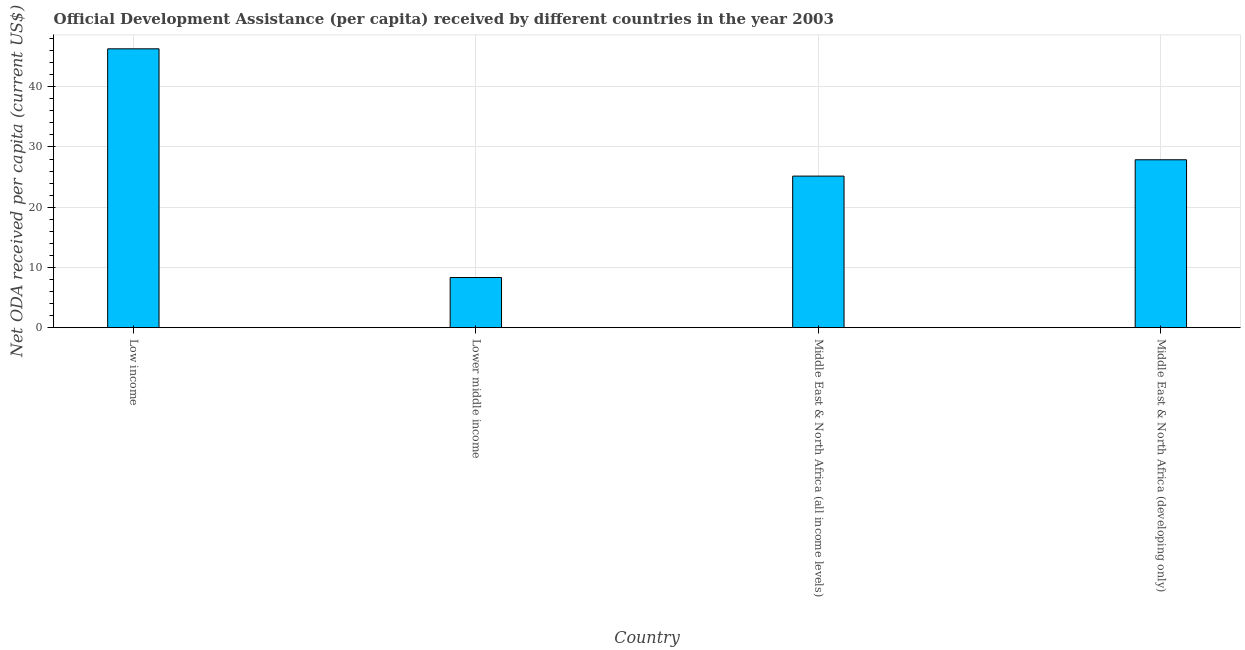Does the graph contain grids?
Make the answer very short. Yes. What is the title of the graph?
Offer a very short reply. Official Development Assistance (per capita) received by different countries in the year 2003. What is the label or title of the Y-axis?
Ensure brevity in your answer.  Net ODA received per capita (current US$). What is the net oda received per capita in Middle East & North Africa (developing only)?
Give a very brief answer. 27.88. Across all countries, what is the maximum net oda received per capita?
Provide a succinct answer. 46.3. Across all countries, what is the minimum net oda received per capita?
Offer a very short reply. 8.33. In which country was the net oda received per capita minimum?
Give a very brief answer. Lower middle income. What is the sum of the net oda received per capita?
Your answer should be compact. 107.67. What is the difference between the net oda received per capita in Low income and Lower middle income?
Offer a terse response. 37.98. What is the average net oda received per capita per country?
Your answer should be very brief. 26.92. What is the median net oda received per capita?
Provide a short and direct response. 26.52. In how many countries, is the net oda received per capita greater than 6 US$?
Keep it short and to the point. 4. What is the ratio of the net oda received per capita in Low income to that in Middle East & North Africa (all income levels)?
Provide a short and direct response. 1.84. Is the net oda received per capita in Low income less than that in Middle East & North Africa (all income levels)?
Keep it short and to the point. No. What is the difference between the highest and the second highest net oda received per capita?
Your answer should be very brief. 18.42. What is the difference between the highest and the lowest net oda received per capita?
Offer a very short reply. 37.98. In how many countries, is the net oda received per capita greater than the average net oda received per capita taken over all countries?
Your answer should be very brief. 2. Are all the bars in the graph horizontal?
Provide a short and direct response. No. How many countries are there in the graph?
Ensure brevity in your answer.  4. What is the Net ODA received per capita (current US$) in Low income?
Give a very brief answer. 46.3. What is the Net ODA received per capita (current US$) in Lower middle income?
Ensure brevity in your answer.  8.33. What is the Net ODA received per capita (current US$) in Middle East & North Africa (all income levels)?
Offer a terse response. 25.17. What is the Net ODA received per capita (current US$) in Middle East & North Africa (developing only)?
Provide a succinct answer. 27.88. What is the difference between the Net ODA received per capita (current US$) in Low income and Lower middle income?
Provide a short and direct response. 37.98. What is the difference between the Net ODA received per capita (current US$) in Low income and Middle East & North Africa (all income levels)?
Offer a terse response. 21.14. What is the difference between the Net ODA received per capita (current US$) in Low income and Middle East & North Africa (developing only)?
Ensure brevity in your answer.  18.42. What is the difference between the Net ODA received per capita (current US$) in Lower middle income and Middle East & North Africa (all income levels)?
Offer a terse response. -16.84. What is the difference between the Net ODA received per capita (current US$) in Lower middle income and Middle East & North Africa (developing only)?
Ensure brevity in your answer.  -19.55. What is the difference between the Net ODA received per capita (current US$) in Middle East & North Africa (all income levels) and Middle East & North Africa (developing only)?
Your response must be concise. -2.71. What is the ratio of the Net ODA received per capita (current US$) in Low income to that in Lower middle income?
Keep it short and to the point. 5.56. What is the ratio of the Net ODA received per capita (current US$) in Low income to that in Middle East & North Africa (all income levels)?
Keep it short and to the point. 1.84. What is the ratio of the Net ODA received per capita (current US$) in Low income to that in Middle East & North Africa (developing only)?
Provide a short and direct response. 1.66. What is the ratio of the Net ODA received per capita (current US$) in Lower middle income to that in Middle East & North Africa (all income levels)?
Offer a terse response. 0.33. What is the ratio of the Net ODA received per capita (current US$) in Lower middle income to that in Middle East & North Africa (developing only)?
Your answer should be very brief. 0.3. What is the ratio of the Net ODA received per capita (current US$) in Middle East & North Africa (all income levels) to that in Middle East & North Africa (developing only)?
Provide a succinct answer. 0.9. 